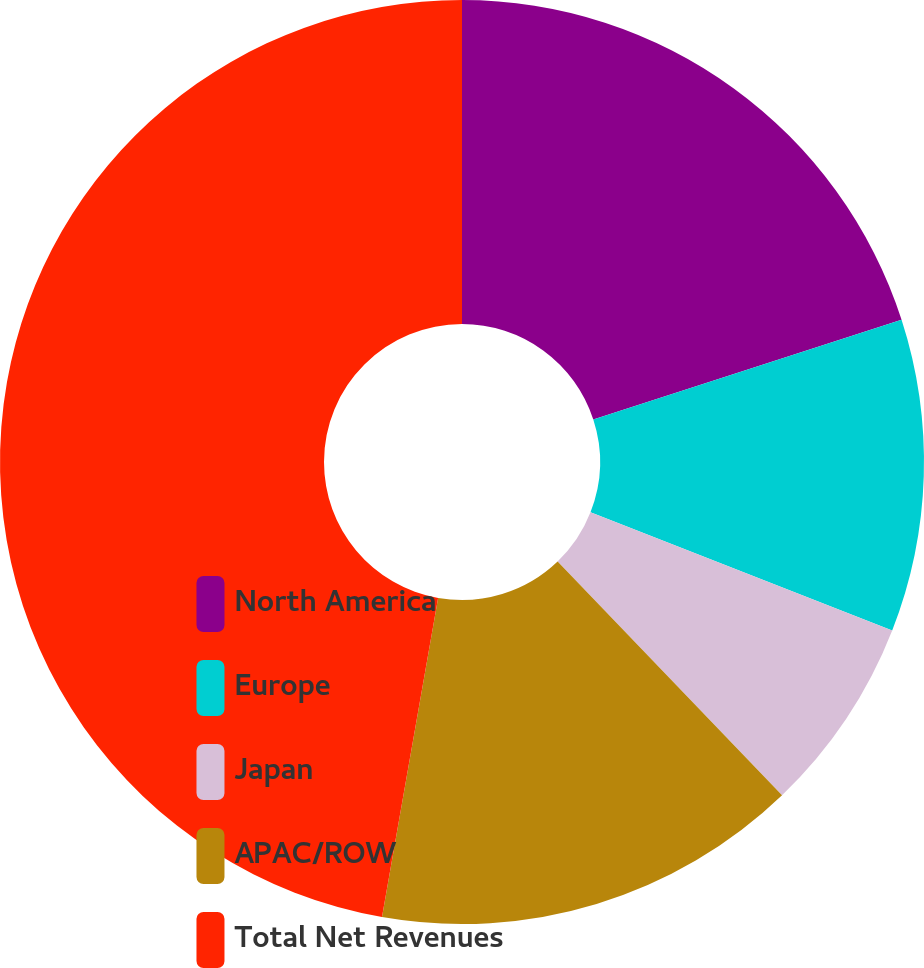Convert chart to OTSL. <chart><loc_0><loc_0><loc_500><loc_500><pie_chart><fcel>North America<fcel>Europe<fcel>Japan<fcel>APAC/ROW<fcel>Total Net Revenues<nl><fcel>20.02%<fcel>10.92%<fcel>6.88%<fcel>14.95%<fcel>47.23%<nl></chart> 